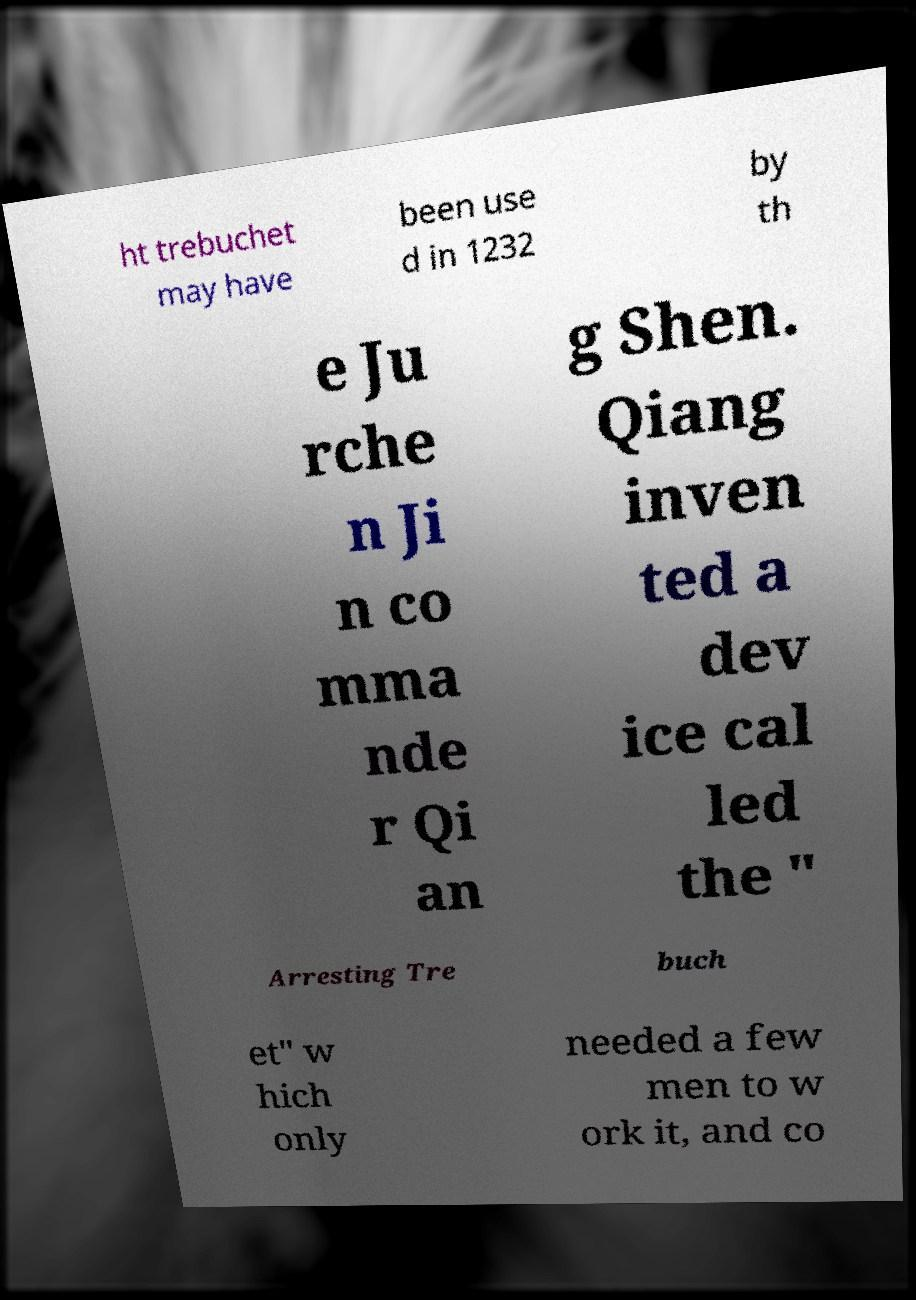Please read and relay the text visible in this image. What does it say? ht trebuchet may have been use d in 1232 by th e Ju rche n Ji n co mma nde r Qi an g Shen. Qiang inven ted a dev ice cal led the " Arresting Tre buch et" w hich only needed a few men to w ork it, and co 